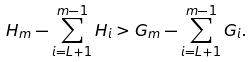Convert formula to latex. <formula><loc_0><loc_0><loc_500><loc_500>H _ { m } - \sum _ { i = L + 1 } ^ { m - 1 } H _ { i } & > G _ { m } - \sum _ { i = L + 1 } ^ { m - 1 } G _ { i } .</formula> 